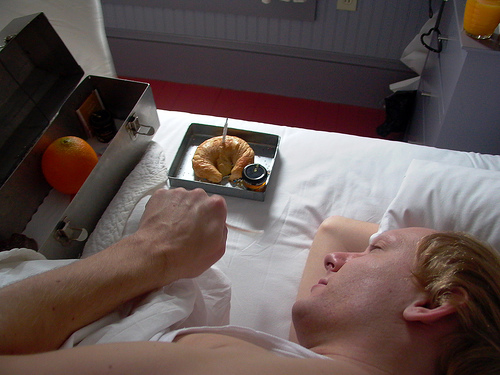<image>
Can you confirm if the food is on the bed? Yes. Looking at the image, I can see the food is positioned on top of the bed, with the bed providing support. 